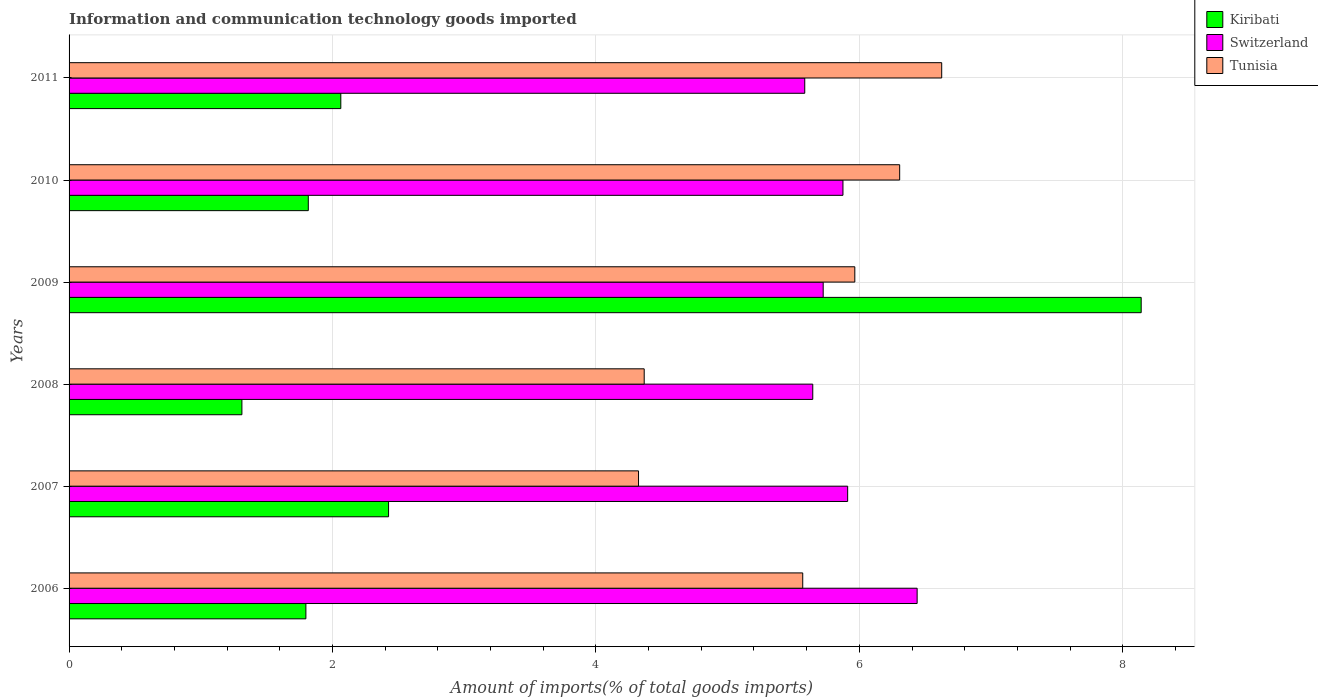How many groups of bars are there?
Your answer should be compact. 6. Are the number of bars on each tick of the Y-axis equal?
Provide a short and direct response. Yes. What is the label of the 5th group of bars from the top?
Your answer should be very brief. 2007. What is the amount of goods imported in Tunisia in 2007?
Keep it short and to the point. 4.32. Across all years, what is the maximum amount of goods imported in Kiribati?
Offer a very short reply. 8.14. Across all years, what is the minimum amount of goods imported in Kiribati?
Your answer should be very brief. 1.31. What is the total amount of goods imported in Kiribati in the graph?
Offer a very short reply. 17.55. What is the difference between the amount of goods imported in Kiribati in 2006 and that in 2009?
Ensure brevity in your answer.  -6.34. What is the difference between the amount of goods imported in Switzerland in 2011 and the amount of goods imported in Kiribati in 2007?
Your response must be concise. 3.16. What is the average amount of goods imported in Switzerland per year?
Make the answer very short. 5.86. In the year 2008, what is the difference between the amount of goods imported in Switzerland and amount of goods imported in Kiribati?
Keep it short and to the point. 4.33. What is the ratio of the amount of goods imported in Switzerland in 2006 to that in 2007?
Your answer should be compact. 1.09. Is the difference between the amount of goods imported in Switzerland in 2006 and 2010 greater than the difference between the amount of goods imported in Kiribati in 2006 and 2010?
Your answer should be compact. Yes. What is the difference between the highest and the second highest amount of goods imported in Switzerland?
Ensure brevity in your answer.  0.53. What is the difference between the highest and the lowest amount of goods imported in Switzerland?
Your answer should be very brief. 0.85. What does the 2nd bar from the top in 2010 represents?
Offer a very short reply. Switzerland. What does the 3rd bar from the bottom in 2009 represents?
Give a very brief answer. Tunisia. Is it the case that in every year, the sum of the amount of goods imported in Tunisia and amount of goods imported in Switzerland is greater than the amount of goods imported in Kiribati?
Offer a terse response. Yes. How many bars are there?
Offer a terse response. 18. How many years are there in the graph?
Your response must be concise. 6. Are the values on the major ticks of X-axis written in scientific E-notation?
Provide a succinct answer. No. Does the graph contain any zero values?
Provide a short and direct response. No. Does the graph contain grids?
Your answer should be very brief. Yes. Where does the legend appear in the graph?
Offer a very short reply. Top right. How are the legend labels stacked?
Your answer should be very brief. Vertical. What is the title of the graph?
Offer a very short reply. Information and communication technology goods imported. Does "Burkina Faso" appear as one of the legend labels in the graph?
Give a very brief answer. No. What is the label or title of the X-axis?
Your answer should be compact. Amount of imports(% of total goods imports). What is the Amount of imports(% of total goods imports) in Kiribati in 2006?
Make the answer very short. 1.8. What is the Amount of imports(% of total goods imports) in Switzerland in 2006?
Your response must be concise. 6.44. What is the Amount of imports(% of total goods imports) of Tunisia in 2006?
Offer a terse response. 5.57. What is the Amount of imports(% of total goods imports) of Kiribati in 2007?
Provide a succinct answer. 2.43. What is the Amount of imports(% of total goods imports) in Switzerland in 2007?
Give a very brief answer. 5.91. What is the Amount of imports(% of total goods imports) of Tunisia in 2007?
Your response must be concise. 4.32. What is the Amount of imports(% of total goods imports) in Kiribati in 2008?
Your response must be concise. 1.31. What is the Amount of imports(% of total goods imports) of Switzerland in 2008?
Ensure brevity in your answer.  5.65. What is the Amount of imports(% of total goods imports) in Tunisia in 2008?
Make the answer very short. 4.37. What is the Amount of imports(% of total goods imports) in Kiribati in 2009?
Your response must be concise. 8.14. What is the Amount of imports(% of total goods imports) of Switzerland in 2009?
Make the answer very short. 5.73. What is the Amount of imports(% of total goods imports) in Tunisia in 2009?
Ensure brevity in your answer.  5.97. What is the Amount of imports(% of total goods imports) in Kiribati in 2010?
Ensure brevity in your answer.  1.82. What is the Amount of imports(% of total goods imports) in Switzerland in 2010?
Ensure brevity in your answer.  5.88. What is the Amount of imports(% of total goods imports) in Tunisia in 2010?
Ensure brevity in your answer.  6.31. What is the Amount of imports(% of total goods imports) of Kiribati in 2011?
Provide a short and direct response. 2.06. What is the Amount of imports(% of total goods imports) of Switzerland in 2011?
Keep it short and to the point. 5.59. What is the Amount of imports(% of total goods imports) in Tunisia in 2011?
Offer a very short reply. 6.63. Across all years, what is the maximum Amount of imports(% of total goods imports) in Kiribati?
Provide a short and direct response. 8.14. Across all years, what is the maximum Amount of imports(% of total goods imports) of Switzerland?
Provide a short and direct response. 6.44. Across all years, what is the maximum Amount of imports(% of total goods imports) of Tunisia?
Offer a very short reply. 6.63. Across all years, what is the minimum Amount of imports(% of total goods imports) in Kiribati?
Offer a very short reply. 1.31. Across all years, what is the minimum Amount of imports(% of total goods imports) of Switzerland?
Offer a very short reply. 5.59. Across all years, what is the minimum Amount of imports(% of total goods imports) in Tunisia?
Offer a terse response. 4.32. What is the total Amount of imports(% of total goods imports) in Kiribati in the graph?
Your answer should be compact. 17.55. What is the total Amount of imports(% of total goods imports) in Switzerland in the graph?
Your answer should be compact. 35.18. What is the total Amount of imports(% of total goods imports) in Tunisia in the graph?
Give a very brief answer. 33.16. What is the difference between the Amount of imports(% of total goods imports) in Kiribati in 2006 and that in 2007?
Your response must be concise. -0.63. What is the difference between the Amount of imports(% of total goods imports) of Switzerland in 2006 and that in 2007?
Give a very brief answer. 0.53. What is the difference between the Amount of imports(% of total goods imports) in Tunisia in 2006 and that in 2007?
Your answer should be very brief. 1.25. What is the difference between the Amount of imports(% of total goods imports) of Kiribati in 2006 and that in 2008?
Offer a terse response. 0.49. What is the difference between the Amount of imports(% of total goods imports) in Switzerland in 2006 and that in 2008?
Your answer should be very brief. 0.79. What is the difference between the Amount of imports(% of total goods imports) in Tunisia in 2006 and that in 2008?
Make the answer very short. 1.2. What is the difference between the Amount of imports(% of total goods imports) in Kiribati in 2006 and that in 2009?
Offer a very short reply. -6.34. What is the difference between the Amount of imports(% of total goods imports) of Switzerland in 2006 and that in 2009?
Ensure brevity in your answer.  0.71. What is the difference between the Amount of imports(% of total goods imports) of Tunisia in 2006 and that in 2009?
Your response must be concise. -0.4. What is the difference between the Amount of imports(% of total goods imports) of Kiribati in 2006 and that in 2010?
Your response must be concise. -0.02. What is the difference between the Amount of imports(% of total goods imports) of Switzerland in 2006 and that in 2010?
Make the answer very short. 0.56. What is the difference between the Amount of imports(% of total goods imports) of Tunisia in 2006 and that in 2010?
Offer a very short reply. -0.74. What is the difference between the Amount of imports(% of total goods imports) in Kiribati in 2006 and that in 2011?
Your answer should be very brief. -0.27. What is the difference between the Amount of imports(% of total goods imports) of Switzerland in 2006 and that in 2011?
Offer a very short reply. 0.85. What is the difference between the Amount of imports(% of total goods imports) in Tunisia in 2006 and that in 2011?
Ensure brevity in your answer.  -1.06. What is the difference between the Amount of imports(% of total goods imports) in Kiribati in 2007 and that in 2008?
Offer a terse response. 1.11. What is the difference between the Amount of imports(% of total goods imports) of Switzerland in 2007 and that in 2008?
Offer a very short reply. 0.27. What is the difference between the Amount of imports(% of total goods imports) in Tunisia in 2007 and that in 2008?
Give a very brief answer. -0.04. What is the difference between the Amount of imports(% of total goods imports) of Kiribati in 2007 and that in 2009?
Your response must be concise. -5.71. What is the difference between the Amount of imports(% of total goods imports) of Switzerland in 2007 and that in 2009?
Your response must be concise. 0.19. What is the difference between the Amount of imports(% of total goods imports) in Tunisia in 2007 and that in 2009?
Keep it short and to the point. -1.64. What is the difference between the Amount of imports(% of total goods imports) of Kiribati in 2007 and that in 2010?
Keep it short and to the point. 0.61. What is the difference between the Amount of imports(% of total goods imports) in Switzerland in 2007 and that in 2010?
Offer a terse response. 0.04. What is the difference between the Amount of imports(% of total goods imports) of Tunisia in 2007 and that in 2010?
Provide a succinct answer. -1.98. What is the difference between the Amount of imports(% of total goods imports) in Kiribati in 2007 and that in 2011?
Your answer should be compact. 0.36. What is the difference between the Amount of imports(% of total goods imports) of Switzerland in 2007 and that in 2011?
Ensure brevity in your answer.  0.33. What is the difference between the Amount of imports(% of total goods imports) of Tunisia in 2007 and that in 2011?
Offer a very short reply. -2.3. What is the difference between the Amount of imports(% of total goods imports) in Kiribati in 2008 and that in 2009?
Provide a short and direct response. -6.83. What is the difference between the Amount of imports(% of total goods imports) in Switzerland in 2008 and that in 2009?
Your answer should be compact. -0.08. What is the difference between the Amount of imports(% of total goods imports) in Tunisia in 2008 and that in 2009?
Ensure brevity in your answer.  -1.6. What is the difference between the Amount of imports(% of total goods imports) in Kiribati in 2008 and that in 2010?
Provide a succinct answer. -0.5. What is the difference between the Amount of imports(% of total goods imports) of Switzerland in 2008 and that in 2010?
Offer a terse response. -0.23. What is the difference between the Amount of imports(% of total goods imports) of Tunisia in 2008 and that in 2010?
Offer a terse response. -1.94. What is the difference between the Amount of imports(% of total goods imports) of Kiribati in 2008 and that in 2011?
Ensure brevity in your answer.  -0.75. What is the difference between the Amount of imports(% of total goods imports) in Switzerland in 2008 and that in 2011?
Give a very brief answer. 0.06. What is the difference between the Amount of imports(% of total goods imports) in Tunisia in 2008 and that in 2011?
Provide a succinct answer. -2.26. What is the difference between the Amount of imports(% of total goods imports) of Kiribati in 2009 and that in 2010?
Make the answer very short. 6.32. What is the difference between the Amount of imports(% of total goods imports) of Switzerland in 2009 and that in 2010?
Give a very brief answer. -0.15. What is the difference between the Amount of imports(% of total goods imports) in Tunisia in 2009 and that in 2010?
Your response must be concise. -0.34. What is the difference between the Amount of imports(% of total goods imports) of Kiribati in 2009 and that in 2011?
Provide a short and direct response. 6.08. What is the difference between the Amount of imports(% of total goods imports) in Switzerland in 2009 and that in 2011?
Provide a short and direct response. 0.14. What is the difference between the Amount of imports(% of total goods imports) in Tunisia in 2009 and that in 2011?
Your response must be concise. -0.66. What is the difference between the Amount of imports(% of total goods imports) in Kiribati in 2010 and that in 2011?
Provide a short and direct response. -0.25. What is the difference between the Amount of imports(% of total goods imports) in Switzerland in 2010 and that in 2011?
Give a very brief answer. 0.29. What is the difference between the Amount of imports(% of total goods imports) in Tunisia in 2010 and that in 2011?
Your answer should be compact. -0.32. What is the difference between the Amount of imports(% of total goods imports) of Kiribati in 2006 and the Amount of imports(% of total goods imports) of Switzerland in 2007?
Give a very brief answer. -4.11. What is the difference between the Amount of imports(% of total goods imports) in Kiribati in 2006 and the Amount of imports(% of total goods imports) in Tunisia in 2007?
Keep it short and to the point. -2.53. What is the difference between the Amount of imports(% of total goods imports) in Switzerland in 2006 and the Amount of imports(% of total goods imports) in Tunisia in 2007?
Keep it short and to the point. 2.12. What is the difference between the Amount of imports(% of total goods imports) of Kiribati in 2006 and the Amount of imports(% of total goods imports) of Switzerland in 2008?
Offer a very short reply. -3.85. What is the difference between the Amount of imports(% of total goods imports) of Kiribati in 2006 and the Amount of imports(% of total goods imports) of Tunisia in 2008?
Your answer should be compact. -2.57. What is the difference between the Amount of imports(% of total goods imports) of Switzerland in 2006 and the Amount of imports(% of total goods imports) of Tunisia in 2008?
Keep it short and to the point. 2.07. What is the difference between the Amount of imports(% of total goods imports) of Kiribati in 2006 and the Amount of imports(% of total goods imports) of Switzerland in 2009?
Keep it short and to the point. -3.93. What is the difference between the Amount of imports(% of total goods imports) in Kiribati in 2006 and the Amount of imports(% of total goods imports) in Tunisia in 2009?
Your answer should be very brief. -4.17. What is the difference between the Amount of imports(% of total goods imports) of Switzerland in 2006 and the Amount of imports(% of total goods imports) of Tunisia in 2009?
Provide a short and direct response. 0.47. What is the difference between the Amount of imports(% of total goods imports) in Kiribati in 2006 and the Amount of imports(% of total goods imports) in Switzerland in 2010?
Make the answer very short. -4.08. What is the difference between the Amount of imports(% of total goods imports) of Kiribati in 2006 and the Amount of imports(% of total goods imports) of Tunisia in 2010?
Keep it short and to the point. -4.51. What is the difference between the Amount of imports(% of total goods imports) of Switzerland in 2006 and the Amount of imports(% of total goods imports) of Tunisia in 2010?
Your answer should be very brief. 0.13. What is the difference between the Amount of imports(% of total goods imports) of Kiribati in 2006 and the Amount of imports(% of total goods imports) of Switzerland in 2011?
Provide a short and direct response. -3.79. What is the difference between the Amount of imports(% of total goods imports) in Kiribati in 2006 and the Amount of imports(% of total goods imports) in Tunisia in 2011?
Ensure brevity in your answer.  -4.83. What is the difference between the Amount of imports(% of total goods imports) in Switzerland in 2006 and the Amount of imports(% of total goods imports) in Tunisia in 2011?
Offer a very short reply. -0.19. What is the difference between the Amount of imports(% of total goods imports) of Kiribati in 2007 and the Amount of imports(% of total goods imports) of Switzerland in 2008?
Keep it short and to the point. -3.22. What is the difference between the Amount of imports(% of total goods imports) of Kiribati in 2007 and the Amount of imports(% of total goods imports) of Tunisia in 2008?
Ensure brevity in your answer.  -1.94. What is the difference between the Amount of imports(% of total goods imports) of Switzerland in 2007 and the Amount of imports(% of total goods imports) of Tunisia in 2008?
Ensure brevity in your answer.  1.54. What is the difference between the Amount of imports(% of total goods imports) in Kiribati in 2007 and the Amount of imports(% of total goods imports) in Switzerland in 2009?
Ensure brevity in your answer.  -3.3. What is the difference between the Amount of imports(% of total goods imports) in Kiribati in 2007 and the Amount of imports(% of total goods imports) in Tunisia in 2009?
Offer a terse response. -3.54. What is the difference between the Amount of imports(% of total goods imports) in Switzerland in 2007 and the Amount of imports(% of total goods imports) in Tunisia in 2009?
Provide a short and direct response. -0.05. What is the difference between the Amount of imports(% of total goods imports) of Kiribati in 2007 and the Amount of imports(% of total goods imports) of Switzerland in 2010?
Offer a terse response. -3.45. What is the difference between the Amount of imports(% of total goods imports) in Kiribati in 2007 and the Amount of imports(% of total goods imports) in Tunisia in 2010?
Offer a very short reply. -3.88. What is the difference between the Amount of imports(% of total goods imports) in Switzerland in 2007 and the Amount of imports(% of total goods imports) in Tunisia in 2010?
Offer a terse response. -0.39. What is the difference between the Amount of imports(% of total goods imports) in Kiribati in 2007 and the Amount of imports(% of total goods imports) in Switzerland in 2011?
Provide a succinct answer. -3.16. What is the difference between the Amount of imports(% of total goods imports) of Kiribati in 2007 and the Amount of imports(% of total goods imports) of Tunisia in 2011?
Your response must be concise. -4.2. What is the difference between the Amount of imports(% of total goods imports) in Switzerland in 2007 and the Amount of imports(% of total goods imports) in Tunisia in 2011?
Offer a terse response. -0.71. What is the difference between the Amount of imports(% of total goods imports) of Kiribati in 2008 and the Amount of imports(% of total goods imports) of Switzerland in 2009?
Offer a terse response. -4.41. What is the difference between the Amount of imports(% of total goods imports) in Kiribati in 2008 and the Amount of imports(% of total goods imports) in Tunisia in 2009?
Your response must be concise. -4.65. What is the difference between the Amount of imports(% of total goods imports) of Switzerland in 2008 and the Amount of imports(% of total goods imports) of Tunisia in 2009?
Keep it short and to the point. -0.32. What is the difference between the Amount of imports(% of total goods imports) in Kiribati in 2008 and the Amount of imports(% of total goods imports) in Switzerland in 2010?
Your answer should be very brief. -4.56. What is the difference between the Amount of imports(% of total goods imports) in Kiribati in 2008 and the Amount of imports(% of total goods imports) in Tunisia in 2010?
Ensure brevity in your answer.  -4.99. What is the difference between the Amount of imports(% of total goods imports) in Switzerland in 2008 and the Amount of imports(% of total goods imports) in Tunisia in 2010?
Provide a succinct answer. -0.66. What is the difference between the Amount of imports(% of total goods imports) of Kiribati in 2008 and the Amount of imports(% of total goods imports) of Switzerland in 2011?
Your answer should be compact. -4.27. What is the difference between the Amount of imports(% of total goods imports) in Kiribati in 2008 and the Amount of imports(% of total goods imports) in Tunisia in 2011?
Ensure brevity in your answer.  -5.31. What is the difference between the Amount of imports(% of total goods imports) of Switzerland in 2008 and the Amount of imports(% of total goods imports) of Tunisia in 2011?
Give a very brief answer. -0.98. What is the difference between the Amount of imports(% of total goods imports) of Kiribati in 2009 and the Amount of imports(% of total goods imports) of Switzerland in 2010?
Keep it short and to the point. 2.26. What is the difference between the Amount of imports(% of total goods imports) of Kiribati in 2009 and the Amount of imports(% of total goods imports) of Tunisia in 2010?
Make the answer very short. 1.83. What is the difference between the Amount of imports(% of total goods imports) of Switzerland in 2009 and the Amount of imports(% of total goods imports) of Tunisia in 2010?
Make the answer very short. -0.58. What is the difference between the Amount of imports(% of total goods imports) of Kiribati in 2009 and the Amount of imports(% of total goods imports) of Switzerland in 2011?
Make the answer very short. 2.55. What is the difference between the Amount of imports(% of total goods imports) in Kiribati in 2009 and the Amount of imports(% of total goods imports) in Tunisia in 2011?
Your answer should be very brief. 1.51. What is the difference between the Amount of imports(% of total goods imports) of Switzerland in 2009 and the Amount of imports(% of total goods imports) of Tunisia in 2011?
Keep it short and to the point. -0.9. What is the difference between the Amount of imports(% of total goods imports) of Kiribati in 2010 and the Amount of imports(% of total goods imports) of Switzerland in 2011?
Your response must be concise. -3.77. What is the difference between the Amount of imports(% of total goods imports) of Kiribati in 2010 and the Amount of imports(% of total goods imports) of Tunisia in 2011?
Ensure brevity in your answer.  -4.81. What is the difference between the Amount of imports(% of total goods imports) in Switzerland in 2010 and the Amount of imports(% of total goods imports) in Tunisia in 2011?
Your answer should be compact. -0.75. What is the average Amount of imports(% of total goods imports) of Kiribati per year?
Make the answer very short. 2.93. What is the average Amount of imports(% of total goods imports) in Switzerland per year?
Offer a terse response. 5.86. What is the average Amount of imports(% of total goods imports) in Tunisia per year?
Ensure brevity in your answer.  5.53. In the year 2006, what is the difference between the Amount of imports(% of total goods imports) of Kiribati and Amount of imports(% of total goods imports) of Switzerland?
Your answer should be compact. -4.64. In the year 2006, what is the difference between the Amount of imports(% of total goods imports) in Kiribati and Amount of imports(% of total goods imports) in Tunisia?
Ensure brevity in your answer.  -3.77. In the year 2006, what is the difference between the Amount of imports(% of total goods imports) in Switzerland and Amount of imports(% of total goods imports) in Tunisia?
Ensure brevity in your answer.  0.87. In the year 2007, what is the difference between the Amount of imports(% of total goods imports) of Kiribati and Amount of imports(% of total goods imports) of Switzerland?
Ensure brevity in your answer.  -3.49. In the year 2007, what is the difference between the Amount of imports(% of total goods imports) in Kiribati and Amount of imports(% of total goods imports) in Tunisia?
Provide a succinct answer. -1.9. In the year 2007, what is the difference between the Amount of imports(% of total goods imports) in Switzerland and Amount of imports(% of total goods imports) in Tunisia?
Provide a succinct answer. 1.59. In the year 2008, what is the difference between the Amount of imports(% of total goods imports) of Kiribati and Amount of imports(% of total goods imports) of Switzerland?
Make the answer very short. -4.33. In the year 2008, what is the difference between the Amount of imports(% of total goods imports) of Kiribati and Amount of imports(% of total goods imports) of Tunisia?
Make the answer very short. -3.05. In the year 2008, what is the difference between the Amount of imports(% of total goods imports) of Switzerland and Amount of imports(% of total goods imports) of Tunisia?
Offer a very short reply. 1.28. In the year 2009, what is the difference between the Amount of imports(% of total goods imports) in Kiribati and Amount of imports(% of total goods imports) in Switzerland?
Offer a very short reply. 2.41. In the year 2009, what is the difference between the Amount of imports(% of total goods imports) in Kiribati and Amount of imports(% of total goods imports) in Tunisia?
Provide a short and direct response. 2.17. In the year 2009, what is the difference between the Amount of imports(% of total goods imports) in Switzerland and Amount of imports(% of total goods imports) in Tunisia?
Offer a very short reply. -0.24. In the year 2010, what is the difference between the Amount of imports(% of total goods imports) in Kiribati and Amount of imports(% of total goods imports) in Switzerland?
Offer a very short reply. -4.06. In the year 2010, what is the difference between the Amount of imports(% of total goods imports) of Kiribati and Amount of imports(% of total goods imports) of Tunisia?
Provide a short and direct response. -4.49. In the year 2010, what is the difference between the Amount of imports(% of total goods imports) of Switzerland and Amount of imports(% of total goods imports) of Tunisia?
Provide a short and direct response. -0.43. In the year 2011, what is the difference between the Amount of imports(% of total goods imports) of Kiribati and Amount of imports(% of total goods imports) of Switzerland?
Offer a very short reply. -3.52. In the year 2011, what is the difference between the Amount of imports(% of total goods imports) in Kiribati and Amount of imports(% of total goods imports) in Tunisia?
Your answer should be very brief. -4.56. In the year 2011, what is the difference between the Amount of imports(% of total goods imports) of Switzerland and Amount of imports(% of total goods imports) of Tunisia?
Offer a terse response. -1.04. What is the ratio of the Amount of imports(% of total goods imports) of Kiribati in 2006 to that in 2007?
Provide a short and direct response. 0.74. What is the ratio of the Amount of imports(% of total goods imports) of Switzerland in 2006 to that in 2007?
Ensure brevity in your answer.  1.09. What is the ratio of the Amount of imports(% of total goods imports) of Tunisia in 2006 to that in 2007?
Keep it short and to the point. 1.29. What is the ratio of the Amount of imports(% of total goods imports) of Kiribati in 2006 to that in 2008?
Provide a short and direct response. 1.37. What is the ratio of the Amount of imports(% of total goods imports) in Switzerland in 2006 to that in 2008?
Keep it short and to the point. 1.14. What is the ratio of the Amount of imports(% of total goods imports) of Tunisia in 2006 to that in 2008?
Provide a short and direct response. 1.28. What is the ratio of the Amount of imports(% of total goods imports) of Kiribati in 2006 to that in 2009?
Keep it short and to the point. 0.22. What is the ratio of the Amount of imports(% of total goods imports) of Switzerland in 2006 to that in 2009?
Make the answer very short. 1.12. What is the ratio of the Amount of imports(% of total goods imports) of Tunisia in 2006 to that in 2009?
Provide a succinct answer. 0.93. What is the ratio of the Amount of imports(% of total goods imports) in Kiribati in 2006 to that in 2010?
Offer a very short reply. 0.99. What is the ratio of the Amount of imports(% of total goods imports) of Switzerland in 2006 to that in 2010?
Offer a terse response. 1.1. What is the ratio of the Amount of imports(% of total goods imports) of Tunisia in 2006 to that in 2010?
Provide a succinct answer. 0.88. What is the ratio of the Amount of imports(% of total goods imports) in Kiribati in 2006 to that in 2011?
Give a very brief answer. 0.87. What is the ratio of the Amount of imports(% of total goods imports) in Switzerland in 2006 to that in 2011?
Your response must be concise. 1.15. What is the ratio of the Amount of imports(% of total goods imports) in Tunisia in 2006 to that in 2011?
Your response must be concise. 0.84. What is the ratio of the Amount of imports(% of total goods imports) in Kiribati in 2007 to that in 2008?
Give a very brief answer. 1.85. What is the ratio of the Amount of imports(% of total goods imports) in Switzerland in 2007 to that in 2008?
Your response must be concise. 1.05. What is the ratio of the Amount of imports(% of total goods imports) of Kiribati in 2007 to that in 2009?
Your answer should be very brief. 0.3. What is the ratio of the Amount of imports(% of total goods imports) in Switzerland in 2007 to that in 2009?
Keep it short and to the point. 1.03. What is the ratio of the Amount of imports(% of total goods imports) in Tunisia in 2007 to that in 2009?
Keep it short and to the point. 0.72. What is the ratio of the Amount of imports(% of total goods imports) of Kiribati in 2007 to that in 2010?
Offer a terse response. 1.34. What is the ratio of the Amount of imports(% of total goods imports) of Switzerland in 2007 to that in 2010?
Offer a terse response. 1.01. What is the ratio of the Amount of imports(% of total goods imports) in Tunisia in 2007 to that in 2010?
Offer a very short reply. 0.69. What is the ratio of the Amount of imports(% of total goods imports) in Kiribati in 2007 to that in 2011?
Provide a short and direct response. 1.18. What is the ratio of the Amount of imports(% of total goods imports) in Switzerland in 2007 to that in 2011?
Provide a short and direct response. 1.06. What is the ratio of the Amount of imports(% of total goods imports) in Tunisia in 2007 to that in 2011?
Your answer should be very brief. 0.65. What is the ratio of the Amount of imports(% of total goods imports) of Kiribati in 2008 to that in 2009?
Keep it short and to the point. 0.16. What is the ratio of the Amount of imports(% of total goods imports) of Switzerland in 2008 to that in 2009?
Provide a succinct answer. 0.99. What is the ratio of the Amount of imports(% of total goods imports) of Tunisia in 2008 to that in 2009?
Offer a very short reply. 0.73. What is the ratio of the Amount of imports(% of total goods imports) in Kiribati in 2008 to that in 2010?
Offer a very short reply. 0.72. What is the ratio of the Amount of imports(% of total goods imports) of Tunisia in 2008 to that in 2010?
Keep it short and to the point. 0.69. What is the ratio of the Amount of imports(% of total goods imports) of Kiribati in 2008 to that in 2011?
Offer a very short reply. 0.64. What is the ratio of the Amount of imports(% of total goods imports) in Switzerland in 2008 to that in 2011?
Your response must be concise. 1.01. What is the ratio of the Amount of imports(% of total goods imports) of Tunisia in 2008 to that in 2011?
Make the answer very short. 0.66. What is the ratio of the Amount of imports(% of total goods imports) of Kiribati in 2009 to that in 2010?
Offer a terse response. 4.48. What is the ratio of the Amount of imports(% of total goods imports) of Switzerland in 2009 to that in 2010?
Your answer should be compact. 0.97. What is the ratio of the Amount of imports(% of total goods imports) in Tunisia in 2009 to that in 2010?
Offer a very short reply. 0.95. What is the ratio of the Amount of imports(% of total goods imports) of Kiribati in 2009 to that in 2011?
Your answer should be very brief. 3.95. What is the ratio of the Amount of imports(% of total goods imports) in Switzerland in 2009 to that in 2011?
Provide a succinct answer. 1.03. What is the ratio of the Amount of imports(% of total goods imports) in Tunisia in 2009 to that in 2011?
Offer a very short reply. 0.9. What is the ratio of the Amount of imports(% of total goods imports) in Kiribati in 2010 to that in 2011?
Offer a terse response. 0.88. What is the ratio of the Amount of imports(% of total goods imports) of Switzerland in 2010 to that in 2011?
Your answer should be compact. 1.05. What is the ratio of the Amount of imports(% of total goods imports) of Tunisia in 2010 to that in 2011?
Offer a very short reply. 0.95. What is the difference between the highest and the second highest Amount of imports(% of total goods imports) in Kiribati?
Give a very brief answer. 5.71. What is the difference between the highest and the second highest Amount of imports(% of total goods imports) in Switzerland?
Offer a terse response. 0.53. What is the difference between the highest and the second highest Amount of imports(% of total goods imports) of Tunisia?
Provide a short and direct response. 0.32. What is the difference between the highest and the lowest Amount of imports(% of total goods imports) of Kiribati?
Ensure brevity in your answer.  6.83. What is the difference between the highest and the lowest Amount of imports(% of total goods imports) in Switzerland?
Keep it short and to the point. 0.85. What is the difference between the highest and the lowest Amount of imports(% of total goods imports) of Tunisia?
Your answer should be very brief. 2.3. 